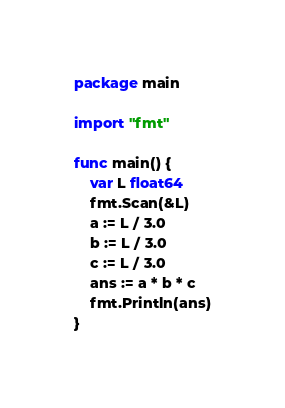Convert code to text. <code><loc_0><loc_0><loc_500><loc_500><_Go_>package main

import "fmt"

func main() {
	var L float64
	fmt.Scan(&L)
	a := L / 3.0
	b := L / 3.0
	c := L / 3.0
	ans := a * b * c
    fmt.Println(ans)
}
</code> 